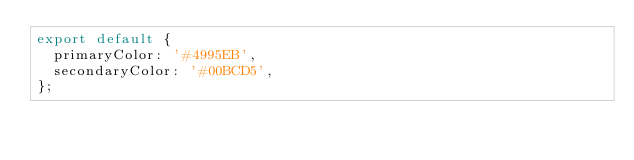Convert code to text. <code><loc_0><loc_0><loc_500><loc_500><_JavaScript_>export default {
  primaryColor: '#4995EB',
  secondaryColor: '#00BCD5',
};
</code> 